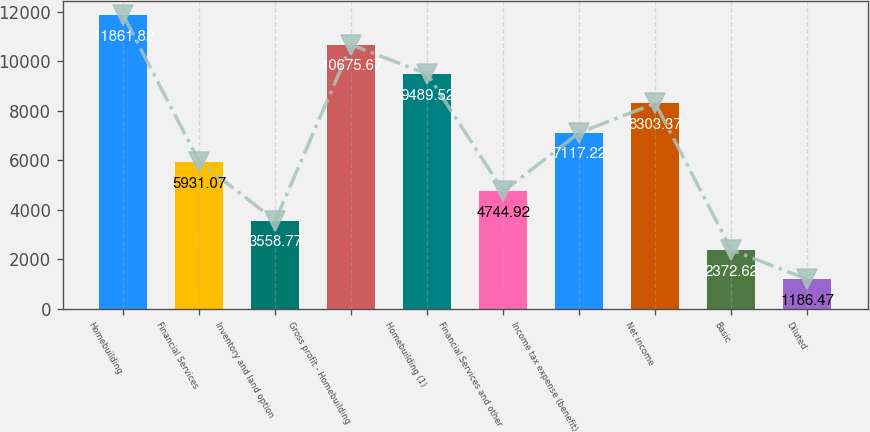Convert chart. <chart><loc_0><loc_0><loc_500><loc_500><bar_chart><fcel>Homebuilding<fcel>Financial Services<fcel>Inventory and land option<fcel>Gross profit - Homebuilding<fcel>Homebuilding (1)<fcel>Financial Services and other<fcel>Income tax expense (benefit)<fcel>Net income<fcel>Basic<fcel>Diluted<nl><fcel>11861.8<fcel>5931.07<fcel>3558.77<fcel>10675.7<fcel>9489.52<fcel>4744.92<fcel>7117.22<fcel>8303.37<fcel>2372.62<fcel>1186.47<nl></chart> 